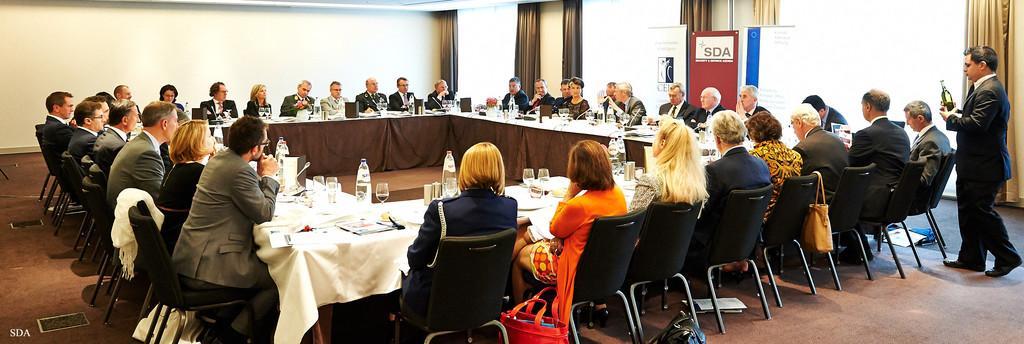Could you give a brief overview of what you see in this image? This is looking like a meeting where a group of people are sitting in a room. There is a person sitting here and he is speaking on a microphone. There is a person on the right side and he is holding a bottle in his hand. 